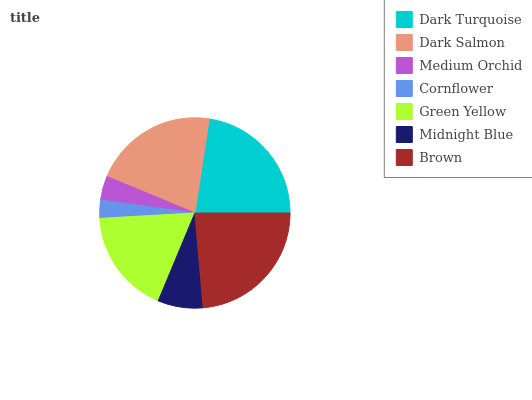Is Cornflower the minimum?
Answer yes or no. Yes. Is Brown the maximum?
Answer yes or no. Yes. Is Dark Salmon the minimum?
Answer yes or no. No. Is Dark Salmon the maximum?
Answer yes or no. No. Is Dark Turquoise greater than Dark Salmon?
Answer yes or no. Yes. Is Dark Salmon less than Dark Turquoise?
Answer yes or no. Yes. Is Dark Salmon greater than Dark Turquoise?
Answer yes or no. No. Is Dark Turquoise less than Dark Salmon?
Answer yes or no. No. Is Green Yellow the high median?
Answer yes or no. Yes. Is Green Yellow the low median?
Answer yes or no. Yes. Is Cornflower the high median?
Answer yes or no. No. Is Medium Orchid the low median?
Answer yes or no. No. 